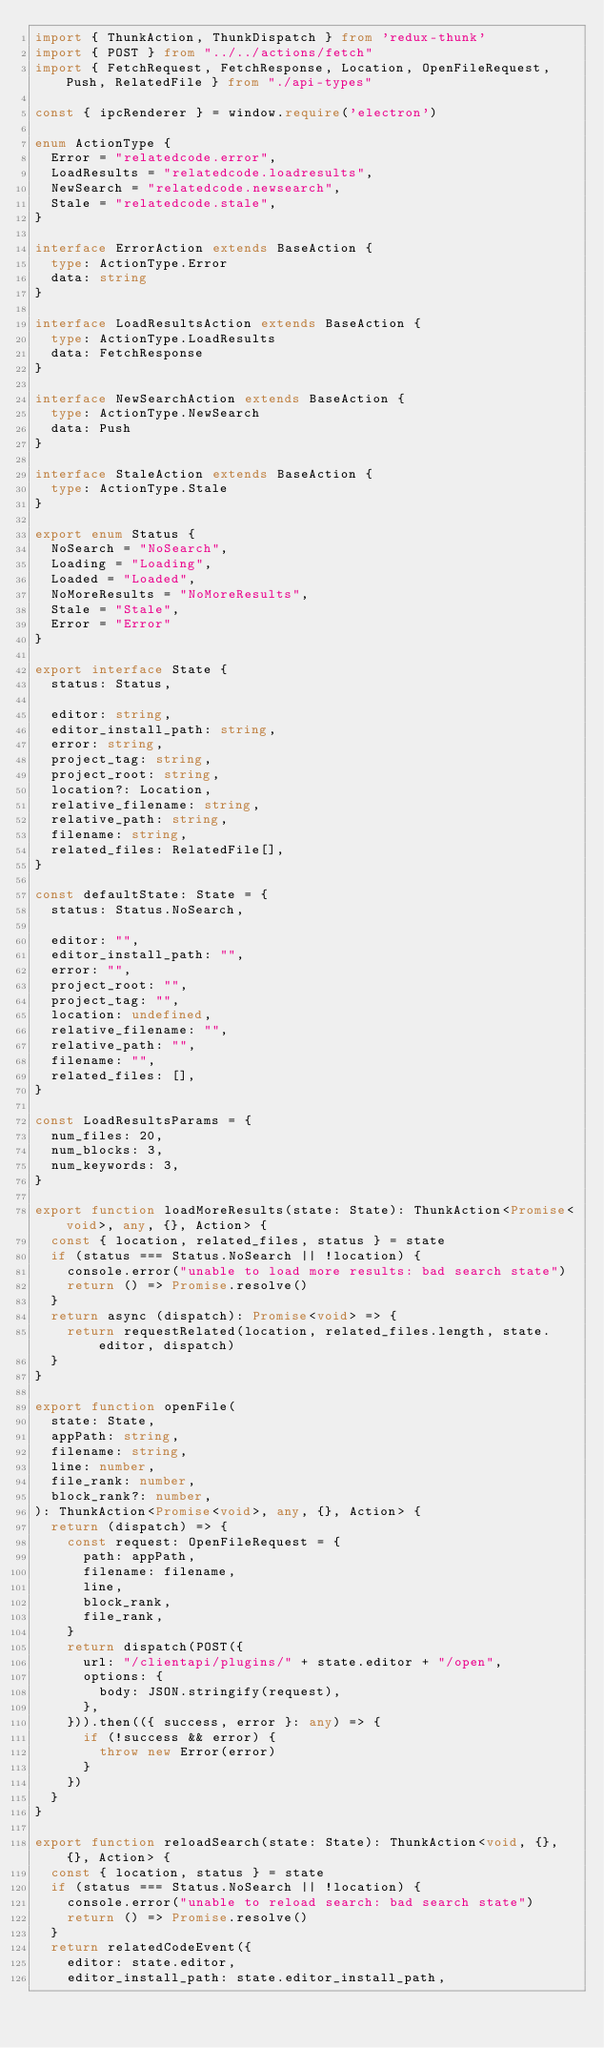<code> <loc_0><loc_0><loc_500><loc_500><_TypeScript_>import { ThunkAction, ThunkDispatch } from 'redux-thunk'
import { POST } from "../../actions/fetch"
import { FetchRequest, FetchResponse, Location, OpenFileRequest, Push, RelatedFile } from "./api-types"

const { ipcRenderer } = window.require('electron')

enum ActionType {
  Error = "relatedcode.error",
  LoadResults = "relatedcode.loadresults",
  NewSearch = "relatedcode.newsearch",
  Stale = "relatedcode.stale",
}

interface ErrorAction extends BaseAction {
  type: ActionType.Error
  data: string
}

interface LoadResultsAction extends BaseAction {
  type: ActionType.LoadResults
  data: FetchResponse
}

interface NewSearchAction extends BaseAction {
  type: ActionType.NewSearch
  data: Push
}

interface StaleAction extends BaseAction {
  type: ActionType.Stale
}

export enum Status {
  NoSearch = "NoSearch",
  Loading = "Loading",
  Loaded = "Loaded",
  NoMoreResults = "NoMoreResults",
  Stale = "Stale",
  Error = "Error"
}

export interface State {
  status: Status,

  editor: string,
  editor_install_path: string,
  error: string,
  project_tag: string,
  project_root: string,
  location?: Location,
  relative_filename: string,
  relative_path: string,
  filename: string,
  related_files: RelatedFile[],
}

const defaultState: State = {
  status: Status.NoSearch,

  editor: "",
  editor_install_path: "",
  error: "",
  project_root: "",
  project_tag: "",
  location: undefined,
  relative_filename: "",
  relative_path: "",
  filename: "",
  related_files: [],
}

const LoadResultsParams = {
  num_files: 20,
  num_blocks: 3,
  num_keywords: 3,
}

export function loadMoreResults(state: State): ThunkAction<Promise<void>, any, {}, Action> {
  const { location, related_files, status } = state
  if (status === Status.NoSearch || !location) {
    console.error("unable to load more results: bad search state")
    return () => Promise.resolve()
  }
  return async (dispatch): Promise<void> => {
    return requestRelated(location, related_files.length, state.editor, dispatch)
  }
}

export function openFile(
  state: State,
  appPath: string,
  filename: string,
  line: number,
  file_rank: number,
  block_rank?: number,
): ThunkAction<Promise<void>, any, {}, Action> {
  return (dispatch) => {
    const request: OpenFileRequest = {
      path: appPath,
      filename: filename,
      line,
      block_rank,
      file_rank,
    }
    return dispatch(POST({
      url: "/clientapi/plugins/" + state.editor + "/open",
      options: {
        body: JSON.stringify(request),
      },
    })).then(({ success, error }: any) => {
      if (!success && error) {
        throw new Error(error)
      }
    })
  }
}

export function reloadSearch(state: State): ThunkAction<void, {}, {}, Action> {
  const { location, status } = state
  if (status === Status.NoSearch || !location) {
    console.error("unable to reload search: bad search state")
    return () => Promise.resolve()
  }
  return relatedCodeEvent({
    editor: state.editor,
    editor_install_path: state.editor_install_path,</code> 